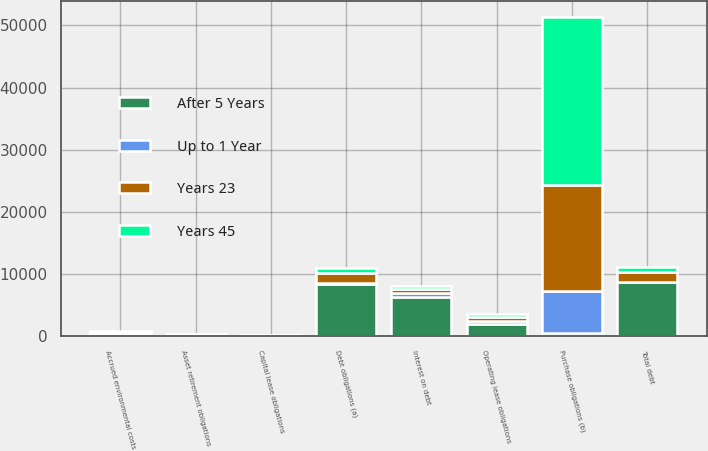<chart> <loc_0><loc_0><loc_500><loc_500><stacked_bar_chart><ecel><fcel>Debt obligations (a)<fcel>Capital lease obligations<fcel>Total debt<fcel>Interest on debt<fcel>Operating lease obligations<fcel>Purchase obligations (b)<fcel>Asset retirement obligations<fcel>Accrued environmental costs<nl><fcel>After 5 Years<fcel>8474<fcel>210<fcel>8684<fcel>6373<fcel>2008<fcel>489<fcel>279<fcel>496<nl><fcel>Years 45<fcel>823<fcel>19<fcel>842<fcel>363<fcel>489<fcel>27161<fcel>8<fcel>84<nl><fcel>Years 23<fcel>1556<fcel>19<fcel>1575<fcel>682<fcel>685<fcel>17023<fcel>10<fcel>113<nl><fcel>Up to 1 Year<fcel>81<fcel>17<fcel>98<fcel>606<fcel>378<fcel>6735<fcel>10<fcel>80<nl></chart> 